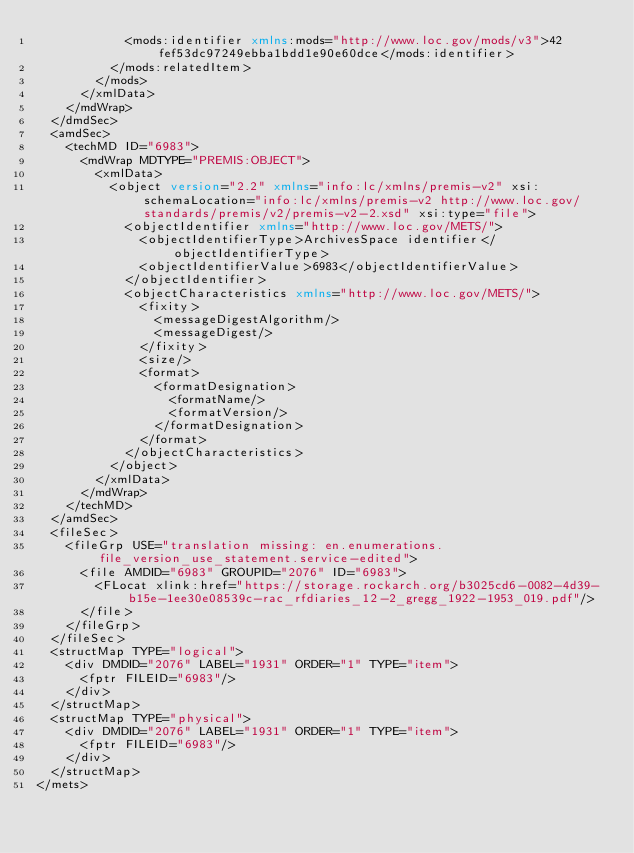<code> <loc_0><loc_0><loc_500><loc_500><_XML_>            <mods:identifier xmlns:mods="http://www.loc.gov/mods/v3">42fef53dc97249ebba1bdd1e90e60dce</mods:identifier>
          </mods:relatedItem>
        </mods>
      </xmlData>
    </mdWrap>
  </dmdSec>
  <amdSec>
    <techMD ID="6983">
      <mdWrap MDTYPE="PREMIS:OBJECT">
        <xmlData>
          <object version="2.2" xmlns="info:lc/xmlns/premis-v2" xsi:schemaLocation="info:lc/xmlns/premis-v2 http://www.loc.gov/standards/premis/v2/premis-v2-2.xsd" xsi:type="file">
            <objectIdentifier xmlns="http://www.loc.gov/METS/">
              <objectIdentifierType>ArchivesSpace identifier</objectIdentifierType>
              <objectIdentifierValue>6983</objectIdentifierValue>
            </objectIdentifier>
            <objectCharacteristics xmlns="http://www.loc.gov/METS/">
              <fixity>
                <messageDigestAlgorithm/>
                <messageDigest/>
              </fixity>
              <size/>
              <format>
                <formatDesignation>
                  <formatName/>
                  <formatVersion/>
                </formatDesignation>
              </format>
            </objectCharacteristics>
          </object>
        </xmlData>
      </mdWrap>
    </techMD>
  </amdSec>
  <fileSec>
    <fileGrp USE="translation missing: en.enumerations.file_version_use_statement.service-edited">
      <file AMDID="6983" GROUPID="2076" ID="6983">
        <FLocat xlink:href="https://storage.rockarch.org/b3025cd6-0082-4d39-b15e-1ee30e08539c-rac_rfdiaries_12-2_gregg_1922-1953_019.pdf"/>
      </file>
    </fileGrp>
  </fileSec>
  <structMap TYPE="logical">
    <div DMDID="2076" LABEL="1931" ORDER="1" TYPE="item">
      <fptr FILEID="6983"/>
    </div>
  </structMap>
  <structMap TYPE="physical">
    <div DMDID="2076" LABEL="1931" ORDER="1" TYPE="item">
      <fptr FILEID="6983"/>
    </div>
  </structMap>
</mets>

</code> 